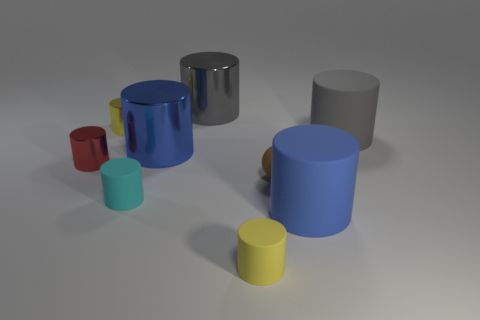Are there any large cylinders in front of the cyan object?
Give a very brief answer. Yes. How many big things are there?
Offer a very short reply. 4. What number of cylinders are behind the big gray thing that is on the right side of the gray metal thing?
Ensure brevity in your answer.  2. Do the tiny matte ball and the big rubber cylinder behind the cyan rubber thing have the same color?
Make the answer very short. No. What number of cyan rubber objects are the same shape as the yellow rubber thing?
Your response must be concise. 1. What is the material of the tiny cylinder behind the big blue shiny cylinder?
Provide a short and direct response. Metal. Does the large matte object that is in front of the small red shiny cylinder have the same shape as the large gray shiny thing?
Your response must be concise. Yes. Are there any blue metallic objects that have the same size as the cyan thing?
Your answer should be compact. No. Is the shape of the small yellow matte object the same as the big blue thing that is right of the brown rubber sphere?
Your answer should be very brief. Yes. Is the number of cyan matte cylinders that are right of the tiny yellow rubber cylinder less than the number of tiny green metal blocks?
Keep it short and to the point. No. 